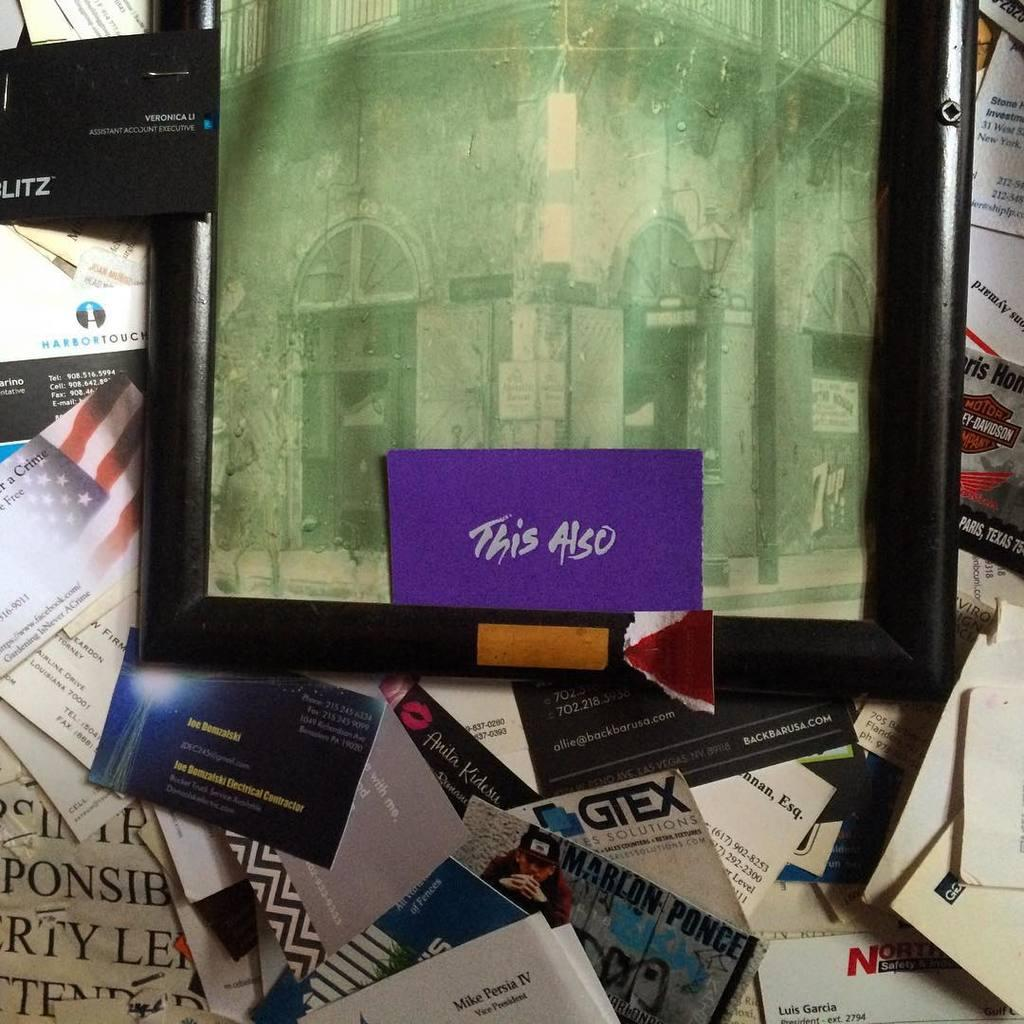<image>
Give a short and clear explanation of the subsequent image. A sface covered in papers and business cards with a picture on top containing a card that reads "this also". 